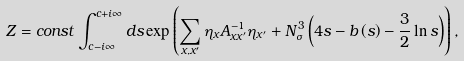<formula> <loc_0><loc_0><loc_500><loc_500>Z = c o n s t \int _ { c - i \infty } ^ { c + i \infty } d s \exp \left ( \sum _ { x , x ^ { \prime } } \eta _ { x } A _ { x x ^ { \prime } } ^ { - 1 } \eta _ { x ^ { \prime } } + N _ { \sigma } ^ { 3 } \left ( 4 s - b \left ( s \right ) - \frac { 3 } { 2 } \ln s \right ) \right ) ,</formula> 